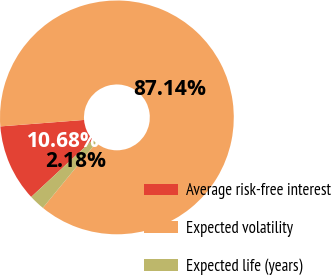Convert chart. <chart><loc_0><loc_0><loc_500><loc_500><pie_chart><fcel>Average risk-free interest<fcel>Expected volatility<fcel>Expected life (years)<nl><fcel>10.68%<fcel>87.15%<fcel>2.18%<nl></chart> 